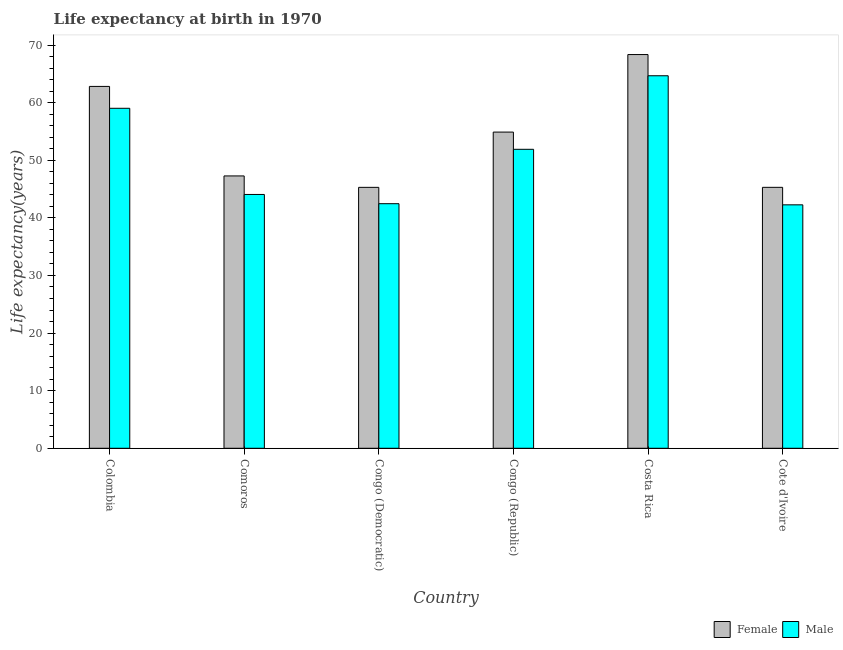How many different coloured bars are there?
Your answer should be compact. 2. How many groups of bars are there?
Provide a short and direct response. 6. Are the number of bars per tick equal to the number of legend labels?
Your answer should be very brief. Yes. Are the number of bars on each tick of the X-axis equal?
Provide a succinct answer. Yes. What is the label of the 2nd group of bars from the left?
Give a very brief answer. Comoros. In how many cases, is the number of bars for a given country not equal to the number of legend labels?
Make the answer very short. 0. What is the life expectancy(female) in Colombia?
Provide a short and direct response. 62.82. Across all countries, what is the maximum life expectancy(male)?
Your answer should be very brief. 64.67. Across all countries, what is the minimum life expectancy(female)?
Your answer should be compact. 45.3. In which country was the life expectancy(male) maximum?
Give a very brief answer. Costa Rica. In which country was the life expectancy(male) minimum?
Make the answer very short. Cote d'Ivoire. What is the total life expectancy(female) in the graph?
Your response must be concise. 323.93. What is the difference between the life expectancy(female) in Congo (Democratic) and that in Costa Rica?
Give a very brief answer. -23.05. What is the difference between the life expectancy(female) in Congo (Republic) and the life expectancy(male) in Costa Rica?
Keep it short and to the point. -9.78. What is the average life expectancy(female) per country?
Your response must be concise. 53.99. What is the difference between the life expectancy(female) and life expectancy(male) in Cote d'Ivoire?
Offer a very short reply. 3.04. In how many countries, is the life expectancy(male) greater than 56 years?
Your answer should be very brief. 2. What is the ratio of the life expectancy(female) in Colombia to that in Congo (Democratic)?
Keep it short and to the point. 1.39. Is the life expectancy(female) in Congo (Democratic) less than that in Costa Rica?
Offer a very short reply. Yes. What is the difference between the highest and the second highest life expectancy(female)?
Your answer should be very brief. 5.53. What is the difference between the highest and the lowest life expectancy(male)?
Provide a succinct answer. 22.41. What does the 1st bar from the right in Congo (Republic) represents?
Offer a terse response. Male. How many bars are there?
Your answer should be very brief. 12. Are all the bars in the graph horizontal?
Offer a very short reply. No. How many countries are there in the graph?
Your answer should be compact. 6. What is the difference between two consecutive major ticks on the Y-axis?
Your answer should be very brief. 10. Does the graph contain grids?
Make the answer very short. No. Where does the legend appear in the graph?
Ensure brevity in your answer.  Bottom right. How many legend labels are there?
Your response must be concise. 2. What is the title of the graph?
Keep it short and to the point. Life expectancy at birth in 1970. Does "External balance on goods" appear as one of the legend labels in the graph?
Your answer should be very brief. No. What is the label or title of the Y-axis?
Offer a terse response. Life expectancy(years). What is the Life expectancy(years) in Female in Colombia?
Your response must be concise. 62.82. What is the Life expectancy(years) in Male in Colombia?
Your answer should be compact. 59.02. What is the Life expectancy(years) of Female in Comoros?
Offer a terse response. 47.28. What is the Life expectancy(years) of Male in Comoros?
Offer a very short reply. 44.06. What is the Life expectancy(years) of Female in Congo (Democratic)?
Give a very brief answer. 45.3. What is the Life expectancy(years) in Male in Congo (Democratic)?
Provide a short and direct response. 42.46. What is the Life expectancy(years) in Female in Congo (Republic)?
Offer a very short reply. 54.89. What is the Life expectancy(years) in Male in Congo (Republic)?
Provide a short and direct response. 51.9. What is the Life expectancy(years) of Female in Costa Rica?
Give a very brief answer. 68.35. What is the Life expectancy(years) in Male in Costa Rica?
Give a very brief answer. 64.67. What is the Life expectancy(years) in Female in Cote d'Ivoire?
Make the answer very short. 45.3. What is the Life expectancy(years) of Male in Cote d'Ivoire?
Your answer should be very brief. 42.26. Across all countries, what is the maximum Life expectancy(years) of Female?
Your answer should be compact. 68.35. Across all countries, what is the maximum Life expectancy(years) in Male?
Offer a very short reply. 64.67. Across all countries, what is the minimum Life expectancy(years) of Female?
Your response must be concise. 45.3. Across all countries, what is the minimum Life expectancy(years) in Male?
Ensure brevity in your answer.  42.26. What is the total Life expectancy(years) of Female in the graph?
Offer a terse response. 323.93. What is the total Life expectancy(years) in Male in the graph?
Your answer should be very brief. 304.37. What is the difference between the Life expectancy(years) of Female in Colombia and that in Comoros?
Your answer should be very brief. 15.54. What is the difference between the Life expectancy(years) in Male in Colombia and that in Comoros?
Your answer should be very brief. 14.96. What is the difference between the Life expectancy(years) in Female in Colombia and that in Congo (Democratic)?
Your response must be concise. 17.52. What is the difference between the Life expectancy(years) in Male in Colombia and that in Congo (Democratic)?
Offer a terse response. 16.56. What is the difference between the Life expectancy(years) of Female in Colombia and that in Congo (Republic)?
Offer a terse response. 7.93. What is the difference between the Life expectancy(years) of Male in Colombia and that in Congo (Republic)?
Keep it short and to the point. 7.12. What is the difference between the Life expectancy(years) of Female in Colombia and that in Costa Rica?
Offer a terse response. -5.53. What is the difference between the Life expectancy(years) of Male in Colombia and that in Costa Rica?
Make the answer very short. -5.65. What is the difference between the Life expectancy(years) in Female in Colombia and that in Cote d'Ivoire?
Provide a succinct answer. 17.52. What is the difference between the Life expectancy(years) of Male in Colombia and that in Cote d'Ivoire?
Offer a very short reply. 16.76. What is the difference between the Life expectancy(years) in Female in Comoros and that in Congo (Democratic)?
Make the answer very short. 1.98. What is the difference between the Life expectancy(years) in Male in Comoros and that in Congo (Democratic)?
Ensure brevity in your answer.  1.6. What is the difference between the Life expectancy(years) in Female in Comoros and that in Congo (Republic)?
Keep it short and to the point. -7.61. What is the difference between the Life expectancy(years) in Male in Comoros and that in Congo (Republic)?
Your answer should be compact. -7.84. What is the difference between the Life expectancy(years) in Female in Comoros and that in Costa Rica?
Your response must be concise. -21.07. What is the difference between the Life expectancy(years) in Male in Comoros and that in Costa Rica?
Give a very brief answer. -20.6. What is the difference between the Life expectancy(years) in Female in Comoros and that in Cote d'Ivoire?
Provide a short and direct response. 1.98. What is the difference between the Life expectancy(years) in Male in Comoros and that in Cote d'Ivoire?
Provide a succinct answer. 1.8. What is the difference between the Life expectancy(years) in Female in Congo (Democratic) and that in Congo (Republic)?
Your answer should be very brief. -9.6. What is the difference between the Life expectancy(years) in Male in Congo (Democratic) and that in Congo (Republic)?
Make the answer very short. -9.44. What is the difference between the Life expectancy(years) of Female in Congo (Democratic) and that in Costa Rica?
Offer a very short reply. -23.05. What is the difference between the Life expectancy(years) in Male in Congo (Democratic) and that in Costa Rica?
Your answer should be very brief. -22.21. What is the difference between the Life expectancy(years) in Female in Congo (Democratic) and that in Cote d'Ivoire?
Ensure brevity in your answer.  -0.01. What is the difference between the Life expectancy(years) of Male in Congo (Democratic) and that in Cote d'Ivoire?
Offer a terse response. 0.2. What is the difference between the Life expectancy(years) in Female in Congo (Republic) and that in Costa Rica?
Provide a short and direct response. -13.46. What is the difference between the Life expectancy(years) in Male in Congo (Republic) and that in Costa Rica?
Provide a succinct answer. -12.77. What is the difference between the Life expectancy(years) of Female in Congo (Republic) and that in Cote d'Ivoire?
Provide a succinct answer. 9.59. What is the difference between the Life expectancy(years) of Male in Congo (Republic) and that in Cote d'Ivoire?
Keep it short and to the point. 9.64. What is the difference between the Life expectancy(years) of Female in Costa Rica and that in Cote d'Ivoire?
Give a very brief answer. 23.05. What is the difference between the Life expectancy(years) in Male in Costa Rica and that in Cote d'Ivoire?
Keep it short and to the point. 22.41. What is the difference between the Life expectancy(years) in Female in Colombia and the Life expectancy(years) in Male in Comoros?
Give a very brief answer. 18.75. What is the difference between the Life expectancy(years) of Female in Colombia and the Life expectancy(years) of Male in Congo (Democratic)?
Your answer should be very brief. 20.36. What is the difference between the Life expectancy(years) in Female in Colombia and the Life expectancy(years) in Male in Congo (Republic)?
Give a very brief answer. 10.92. What is the difference between the Life expectancy(years) of Female in Colombia and the Life expectancy(years) of Male in Costa Rica?
Ensure brevity in your answer.  -1.85. What is the difference between the Life expectancy(years) in Female in Colombia and the Life expectancy(years) in Male in Cote d'Ivoire?
Offer a terse response. 20.56. What is the difference between the Life expectancy(years) of Female in Comoros and the Life expectancy(years) of Male in Congo (Democratic)?
Keep it short and to the point. 4.82. What is the difference between the Life expectancy(years) of Female in Comoros and the Life expectancy(years) of Male in Congo (Republic)?
Keep it short and to the point. -4.62. What is the difference between the Life expectancy(years) in Female in Comoros and the Life expectancy(years) in Male in Costa Rica?
Provide a short and direct response. -17.39. What is the difference between the Life expectancy(years) in Female in Comoros and the Life expectancy(years) in Male in Cote d'Ivoire?
Your answer should be very brief. 5.02. What is the difference between the Life expectancy(years) in Female in Congo (Democratic) and the Life expectancy(years) in Male in Congo (Republic)?
Your response must be concise. -6.61. What is the difference between the Life expectancy(years) in Female in Congo (Democratic) and the Life expectancy(years) in Male in Costa Rica?
Provide a succinct answer. -19.37. What is the difference between the Life expectancy(years) in Female in Congo (Democratic) and the Life expectancy(years) in Male in Cote d'Ivoire?
Your answer should be very brief. 3.03. What is the difference between the Life expectancy(years) in Female in Congo (Republic) and the Life expectancy(years) in Male in Costa Rica?
Give a very brief answer. -9.78. What is the difference between the Life expectancy(years) of Female in Congo (Republic) and the Life expectancy(years) of Male in Cote d'Ivoire?
Give a very brief answer. 12.63. What is the difference between the Life expectancy(years) of Female in Costa Rica and the Life expectancy(years) of Male in Cote d'Ivoire?
Provide a succinct answer. 26.09. What is the average Life expectancy(years) of Female per country?
Make the answer very short. 53.99. What is the average Life expectancy(years) in Male per country?
Give a very brief answer. 50.73. What is the difference between the Life expectancy(years) of Female and Life expectancy(years) of Male in Colombia?
Provide a short and direct response. 3.8. What is the difference between the Life expectancy(years) of Female and Life expectancy(years) of Male in Comoros?
Offer a very short reply. 3.22. What is the difference between the Life expectancy(years) of Female and Life expectancy(years) of Male in Congo (Democratic)?
Your answer should be very brief. 2.83. What is the difference between the Life expectancy(years) of Female and Life expectancy(years) of Male in Congo (Republic)?
Keep it short and to the point. 2.99. What is the difference between the Life expectancy(years) of Female and Life expectancy(years) of Male in Costa Rica?
Ensure brevity in your answer.  3.68. What is the difference between the Life expectancy(years) of Female and Life expectancy(years) of Male in Cote d'Ivoire?
Keep it short and to the point. 3.04. What is the ratio of the Life expectancy(years) of Female in Colombia to that in Comoros?
Give a very brief answer. 1.33. What is the ratio of the Life expectancy(years) of Male in Colombia to that in Comoros?
Offer a terse response. 1.34. What is the ratio of the Life expectancy(years) of Female in Colombia to that in Congo (Democratic)?
Offer a terse response. 1.39. What is the ratio of the Life expectancy(years) of Male in Colombia to that in Congo (Democratic)?
Your response must be concise. 1.39. What is the ratio of the Life expectancy(years) in Female in Colombia to that in Congo (Republic)?
Your response must be concise. 1.14. What is the ratio of the Life expectancy(years) of Male in Colombia to that in Congo (Republic)?
Your response must be concise. 1.14. What is the ratio of the Life expectancy(years) of Female in Colombia to that in Costa Rica?
Your answer should be compact. 0.92. What is the ratio of the Life expectancy(years) of Male in Colombia to that in Costa Rica?
Provide a succinct answer. 0.91. What is the ratio of the Life expectancy(years) of Female in Colombia to that in Cote d'Ivoire?
Offer a very short reply. 1.39. What is the ratio of the Life expectancy(years) in Male in Colombia to that in Cote d'Ivoire?
Offer a terse response. 1.4. What is the ratio of the Life expectancy(years) in Female in Comoros to that in Congo (Democratic)?
Offer a very short reply. 1.04. What is the ratio of the Life expectancy(years) in Male in Comoros to that in Congo (Democratic)?
Your answer should be compact. 1.04. What is the ratio of the Life expectancy(years) in Female in Comoros to that in Congo (Republic)?
Provide a short and direct response. 0.86. What is the ratio of the Life expectancy(years) of Male in Comoros to that in Congo (Republic)?
Keep it short and to the point. 0.85. What is the ratio of the Life expectancy(years) of Female in Comoros to that in Costa Rica?
Ensure brevity in your answer.  0.69. What is the ratio of the Life expectancy(years) in Male in Comoros to that in Costa Rica?
Offer a very short reply. 0.68. What is the ratio of the Life expectancy(years) in Female in Comoros to that in Cote d'Ivoire?
Provide a short and direct response. 1.04. What is the ratio of the Life expectancy(years) in Male in Comoros to that in Cote d'Ivoire?
Provide a short and direct response. 1.04. What is the ratio of the Life expectancy(years) of Female in Congo (Democratic) to that in Congo (Republic)?
Your answer should be compact. 0.83. What is the ratio of the Life expectancy(years) of Male in Congo (Democratic) to that in Congo (Republic)?
Your answer should be very brief. 0.82. What is the ratio of the Life expectancy(years) in Female in Congo (Democratic) to that in Costa Rica?
Your answer should be compact. 0.66. What is the ratio of the Life expectancy(years) in Male in Congo (Democratic) to that in Costa Rica?
Give a very brief answer. 0.66. What is the ratio of the Life expectancy(years) of Female in Congo (Democratic) to that in Cote d'Ivoire?
Your answer should be compact. 1. What is the ratio of the Life expectancy(years) in Female in Congo (Republic) to that in Costa Rica?
Provide a short and direct response. 0.8. What is the ratio of the Life expectancy(years) of Male in Congo (Republic) to that in Costa Rica?
Your answer should be very brief. 0.8. What is the ratio of the Life expectancy(years) in Female in Congo (Republic) to that in Cote d'Ivoire?
Offer a very short reply. 1.21. What is the ratio of the Life expectancy(years) of Male in Congo (Republic) to that in Cote d'Ivoire?
Ensure brevity in your answer.  1.23. What is the ratio of the Life expectancy(years) in Female in Costa Rica to that in Cote d'Ivoire?
Offer a terse response. 1.51. What is the ratio of the Life expectancy(years) in Male in Costa Rica to that in Cote d'Ivoire?
Ensure brevity in your answer.  1.53. What is the difference between the highest and the second highest Life expectancy(years) in Female?
Provide a short and direct response. 5.53. What is the difference between the highest and the second highest Life expectancy(years) of Male?
Offer a very short reply. 5.65. What is the difference between the highest and the lowest Life expectancy(years) of Female?
Your answer should be very brief. 23.05. What is the difference between the highest and the lowest Life expectancy(years) of Male?
Your answer should be compact. 22.41. 